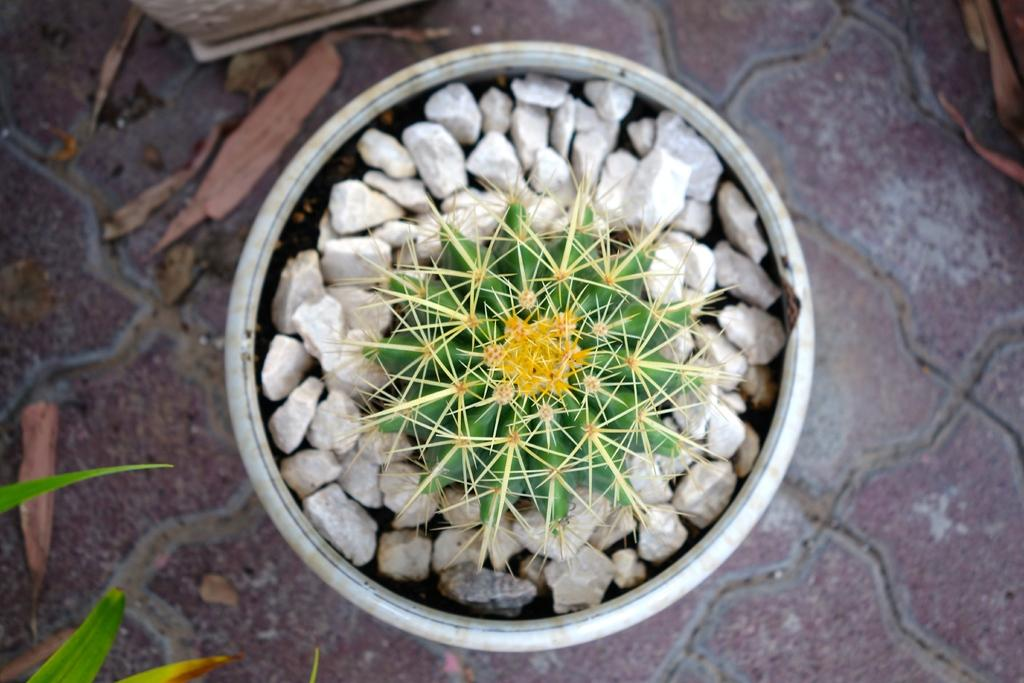What is the main object in the center of the image? There is a plant pot in the center of the image. What is inside the plant pot? There is a plant in the plant pot. Are there any additional elements in the plant pot? Yes, there are stones in the plant pot. What is the condition of the leaves around the pot? Dry leaves and green leaves are present around the pot. What other objects can be seen around the plant pot? There are a few other objects around the pot. Can you tell me how many umbrellas are open in the image? There are no umbrellas present in the image. Is there a guide standing next to the plant pot in the image? There is no guide present in the image. 